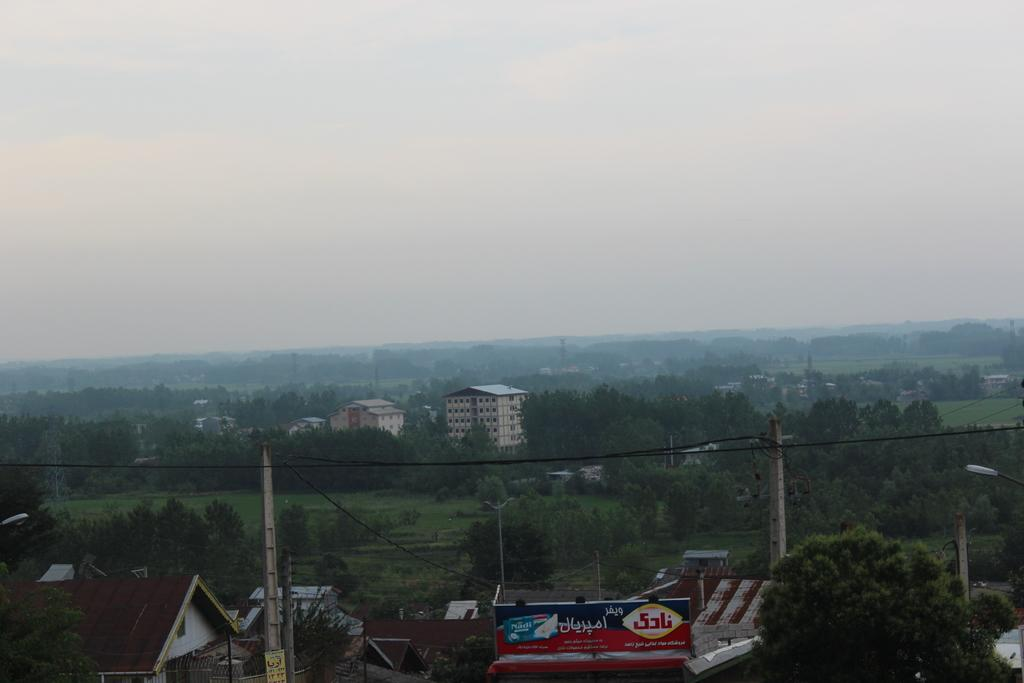What type of structures can be seen in the image? There are buildings in the image. What decorative elements are present in the image? There are banners in the image. What vertical structures can be seen in the image? There are utility poles in the image. What type of vegetation is present in the image? There are trees, plants, and grass in the image. What part of the natural environment is visible in the image? The sky is visible in the image. What type of fork can be seen in the image? There is no fork present in the image. How many apples are hanging from the trees in the image? There are no apples present in the image. 